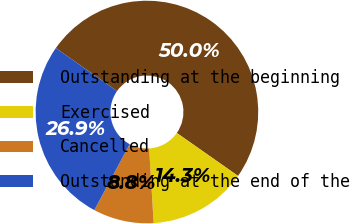Convert chart. <chart><loc_0><loc_0><loc_500><loc_500><pie_chart><fcel>Outstanding at the beginning<fcel>Exercised<fcel>Cancelled<fcel>Outstanding at the end of the<nl><fcel>50.0%<fcel>14.3%<fcel>8.8%<fcel>26.9%<nl></chart> 